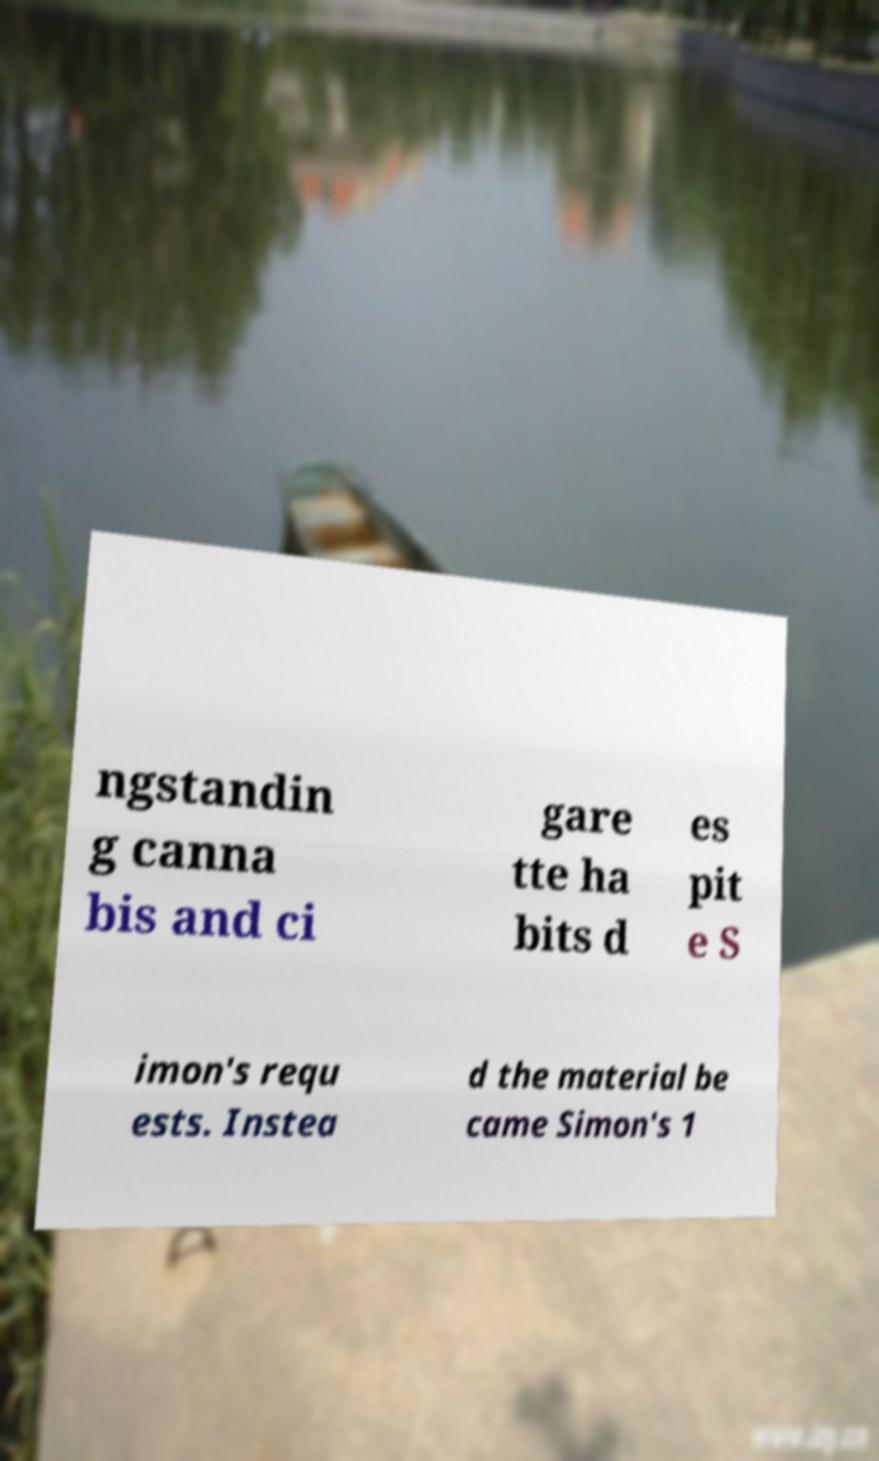Could you extract and type out the text from this image? ngstandin g canna bis and ci gare tte ha bits d es pit e S imon's requ ests. Instea d the material be came Simon's 1 